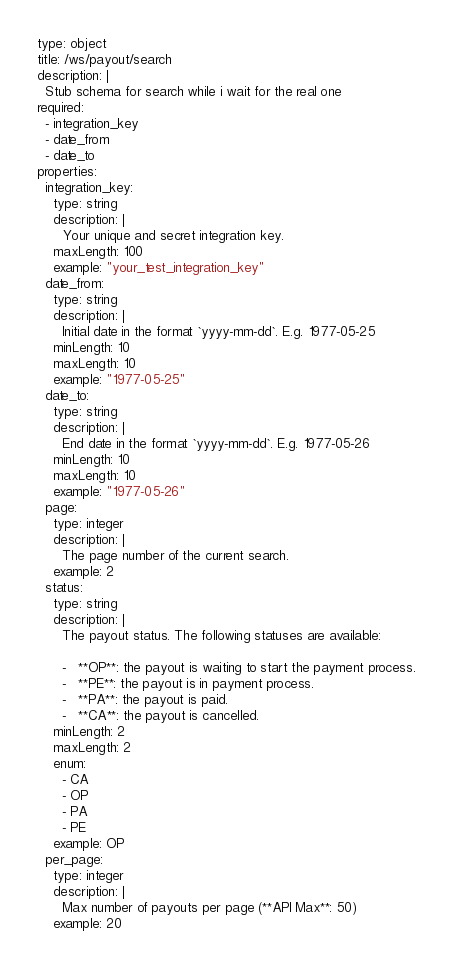Convert code to text. <code><loc_0><loc_0><loc_500><loc_500><_YAML_>type: object 
title: /ws/payout/search
description: |
  Stub schema for search while i wait for the real one
required:
  - integration_key
  - date_from
  - date_to
properties:
  integration_key:
    type: string
    description: |
      Your unique and secret integration key.
    maxLength: 100
    example: "your_test_integration_key"
  date_from:
    type: string
    description: |
      Initial date in the format `yyyy-mm-dd`. E.g. 1977-05-25
    minLength: 10
    maxLength: 10
    example: "1977-05-25"
  date_to:
    type: string
    description: |
      End date in the format `yyyy-mm-dd`. E.g. 1977-05-26
    minLength: 10
    maxLength: 10
    example: "1977-05-26"
  page:
    type: integer
    description: |
      The page number of the current search.
    example: 2
  status:
    type: string
    description: |
      The payout status. The following statuses are available:

      -   **OP**: the payout is waiting to start the payment process.
      -   **PE**: the payout is in payment process.
      -   **PA**: the payout is paid.
      -   **CA**: the payout is cancelled.
    minLength: 2
    maxLength: 2
    enum:
      - CA
      - OP
      - PA
      - PE
    example: OP
  per_page:
    type: integer
    description: |
      Max number of payouts per page (**API Max**: 50)
    example: 20</code> 